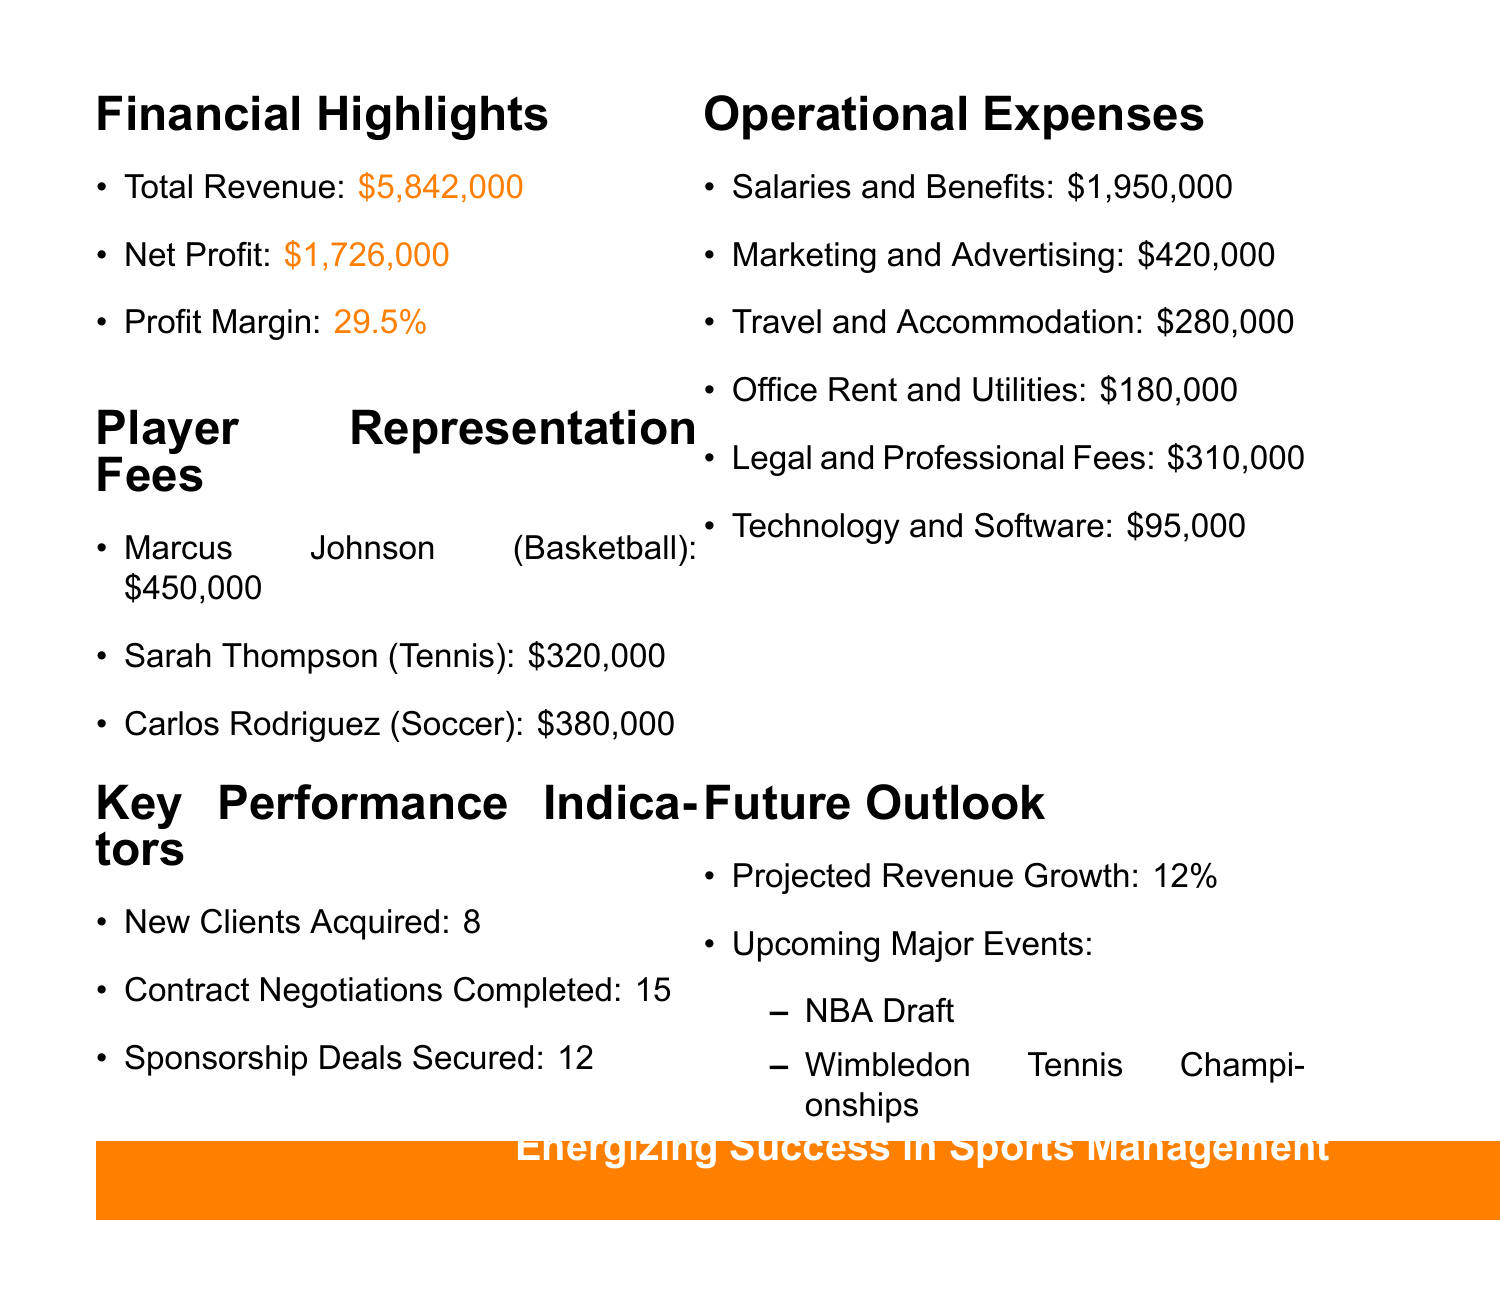What is the total revenue? The total revenue is explicitly stated in the financial highlights section of the document.
Answer: $5,842,000 Who is the player with the highest representation fee? By comparing the player representation fees listed in the document, it is clear that Marcus Johnson has the highest fee.
Answer: Marcus Johnson What percentage is the profit margin? The profit margin is provided in the financial highlights section as a percentage of the net profit relative to the total revenue.
Answer: 29.5% What are the total operational expenses? The total operational expenses can be summed up from the individual expense categories listed in the document.
Answer: $3,415,000 How many new clients were acquired in Q2 2023? The number of new clients acquired is directly stated in the key performance indicators section of the document.
Answer: 8 What is the projected revenue growth for the upcoming quarter? The projected revenue growth is mentioned in the future outlook section of the document.
Answer: 12% Which sporting events are upcoming? The document lists upcoming major events under the future outlook section.
Answer: NBA Draft, Wimbledon Tennis Championships, FIFA World Cup Qualifiers What is the fee for Sarah Thompson? The fee for Sarah Thompson is specifically mentioned in the player representation fees section.
Answer: $320,000 